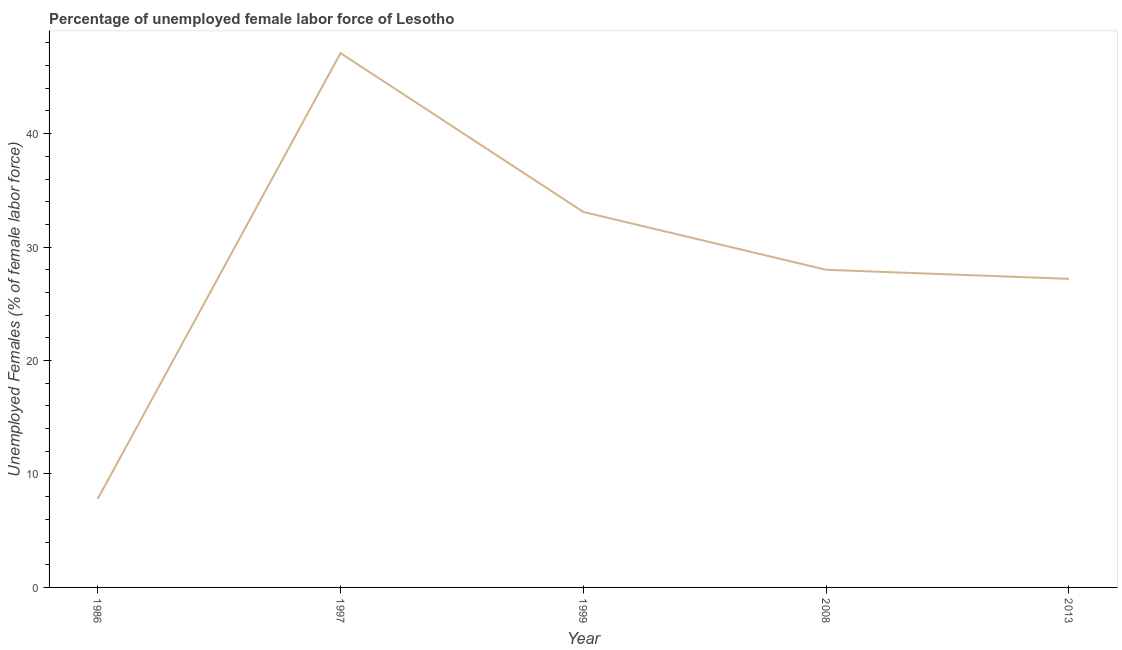What is the total unemployed female labour force in 1986?
Keep it short and to the point. 7.8. Across all years, what is the maximum total unemployed female labour force?
Keep it short and to the point. 47.1. Across all years, what is the minimum total unemployed female labour force?
Offer a terse response. 7.8. In which year was the total unemployed female labour force maximum?
Provide a succinct answer. 1997. In which year was the total unemployed female labour force minimum?
Give a very brief answer. 1986. What is the sum of the total unemployed female labour force?
Ensure brevity in your answer.  143.2. What is the difference between the total unemployed female labour force in 1986 and 1999?
Provide a short and direct response. -25.3. What is the average total unemployed female labour force per year?
Your answer should be compact. 28.64. In how many years, is the total unemployed female labour force greater than 34 %?
Offer a very short reply. 1. What is the ratio of the total unemployed female labour force in 2008 to that in 2013?
Your answer should be very brief. 1.03. Is the total unemployed female labour force in 1997 less than that in 2008?
Your response must be concise. No. What is the difference between the highest and the second highest total unemployed female labour force?
Keep it short and to the point. 14. Is the sum of the total unemployed female labour force in 2008 and 2013 greater than the maximum total unemployed female labour force across all years?
Provide a succinct answer. Yes. What is the difference between the highest and the lowest total unemployed female labour force?
Offer a very short reply. 39.3. Does the total unemployed female labour force monotonically increase over the years?
Give a very brief answer. No. How many lines are there?
Provide a succinct answer. 1. How many years are there in the graph?
Your answer should be very brief. 5. Are the values on the major ticks of Y-axis written in scientific E-notation?
Your answer should be very brief. No. What is the title of the graph?
Your answer should be compact. Percentage of unemployed female labor force of Lesotho. What is the label or title of the Y-axis?
Offer a very short reply. Unemployed Females (% of female labor force). What is the Unemployed Females (% of female labor force) of 1986?
Make the answer very short. 7.8. What is the Unemployed Females (% of female labor force) in 1997?
Give a very brief answer. 47.1. What is the Unemployed Females (% of female labor force) of 1999?
Your answer should be compact. 33.1. What is the Unemployed Females (% of female labor force) of 2008?
Offer a very short reply. 28. What is the Unemployed Females (% of female labor force) in 2013?
Offer a terse response. 27.2. What is the difference between the Unemployed Females (% of female labor force) in 1986 and 1997?
Offer a very short reply. -39.3. What is the difference between the Unemployed Females (% of female labor force) in 1986 and 1999?
Offer a terse response. -25.3. What is the difference between the Unemployed Females (% of female labor force) in 1986 and 2008?
Keep it short and to the point. -20.2. What is the difference between the Unemployed Females (% of female labor force) in 1986 and 2013?
Make the answer very short. -19.4. What is the difference between the Unemployed Females (% of female labor force) in 1997 and 1999?
Provide a short and direct response. 14. What is the difference between the Unemployed Females (% of female labor force) in 1999 and 2008?
Offer a very short reply. 5.1. What is the ratio of the Unemployed Females (% of female labor force) in 1986 to that in 1997?
Ensure brevity in your answer.  0.17. What is the ratio of the Unemployed Females (% of female labor force) in 1986 to that in 1999?
Ensure brevity in your answer.  0.24. What is the ratio of the Unemployed Females (% of female labor force) in 1986 to that in 2008?
Your answer should be very brief. 0.28. What is the ratio of the Unemployed Females (% of female labor force) in 1986 to that in 2013?
Give a very brief answer. 0.29. What is the ratio of the Unemployed Females (% of female labor force) in 1997 to that in 1999?
Provide a succinct answer. 1.42. What is the ratio of the Unemployed Females (% of female labor force) in 1997 to that in 2008?
Give a very brief answer. 1.68. What is the ratio of the Unemployed Females (% of female labor force) in 1997 to that in 2013?
Offer a terse response. 1.73. What is the ratio of the Unemployed Females (% of female labor force) in 1999 to that in 2008?
Provide a short and direct response. 1.18. What is the ratio of the Unemployed Females (% of female labor force) in 1999 to that in 2013?
Keep it short and to the point. 1.22. What is the ratio of the Unemployed Females (% of female labor force) in 2008 to that in 2013?
Your answer should be compact. 1.03. 